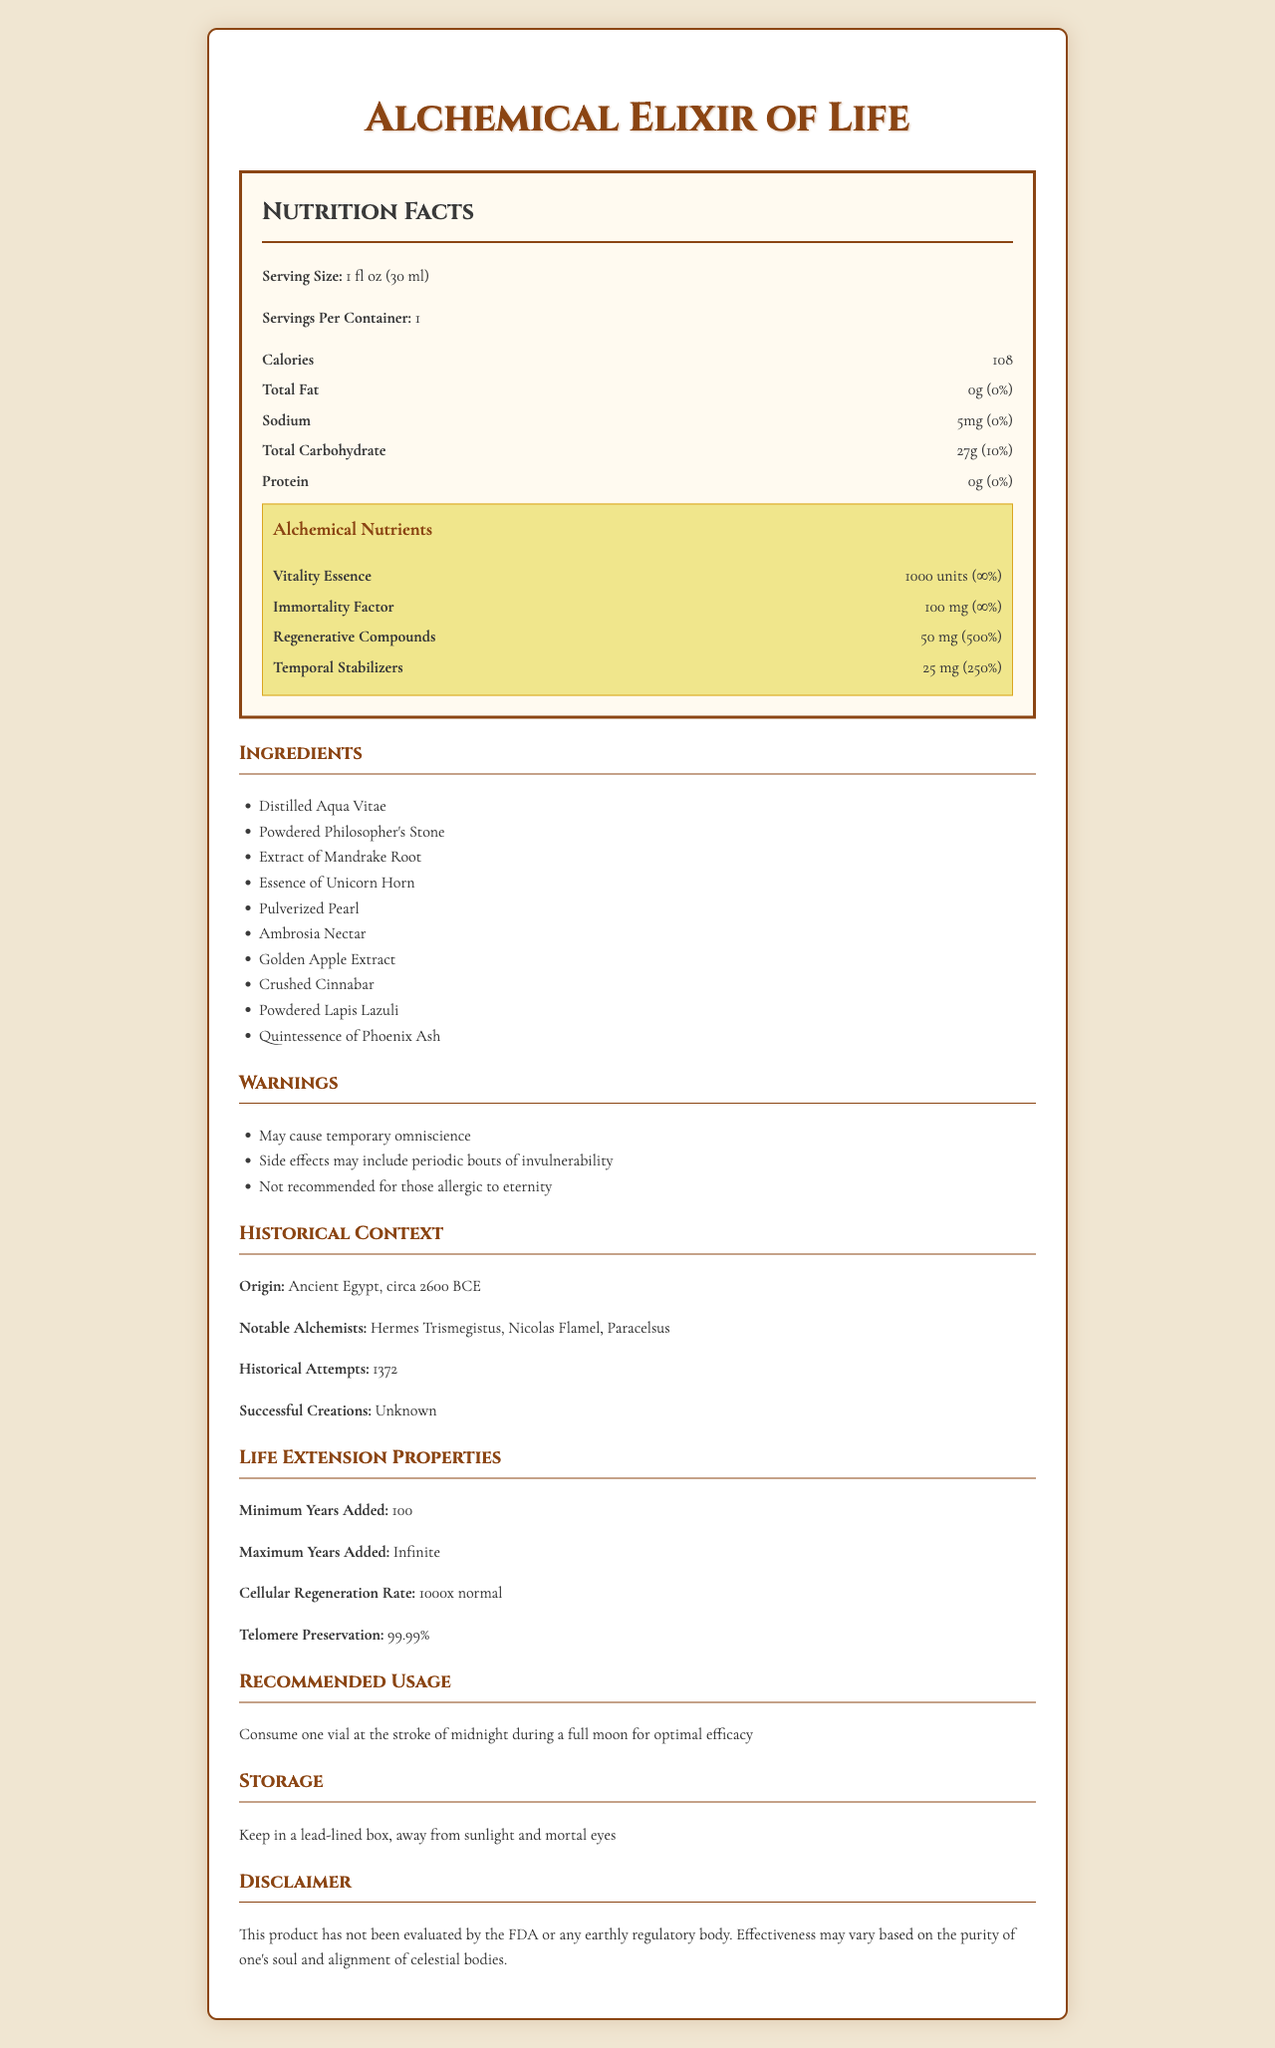what is the serving size? The serving size is specified under the Nutrition Facts section of the document.
Answer: 1 fl oz (30 ml) how many calories are in one serving? The number of calories per serving is listed under the Nutrition Facts section.
Answer: 108 name two ingredients in the alchemical elixir of life. The ingredients list includes items such as Distilled Aqua Vitae and Powdered Philosopher's Stone.
Answer: Distilled Aqua Vitae, Powdered Philosopher's Stone what is the daily value percentage of total carbohydrates? The daily value percentage for total carbohydrates is located under the Nutrition Facts section under Total Carbohydrate.
Answer: 10% what is recommended storage condition for the elixir? The storage recommendation is detailed under the Storage section in the document.
Answer: Keep in a lead-lined box, away from sunlight and mortal eyes which historical figure is NOT mentioned as a notable alchemist? A. Hermes Trismegistus B. Albertus Magnus C. Nicolas Flamel D. Paracelsus The notable alchemists listed are Hermes Trismegistus, Nicolas Flamel, and Paracelsus. Albertus Magnus is not mentioned.
Answer: B. Albertus Magnus what is the primary benefit of consuming the elixir according to the document? A. Increased strength B. Night vision C. Life extension D. Enhanced intelligence The document emphasizes life extension properties like cellular regeneration and telomere preservation.
Answer: C. Life extension does the elixir contain any protein? The Nutrition Facts section lists 0g of protein for the elixir.
Answer: No describe the life-extension properties of the alchemical elixir of life. The document's Life Extension Properties section provides these specifics regarding the elixir's capabilities.
Answer: The elixir has life-extension properties including adding a minimum of 100 years and potentially infinite years to one's lifespan. It boasts a cellular regeneration rate of 1000x normal and preserves telomeres at a rate of 99.99%. who was the first known alchemist to create the elixir of life? The document lists notable alchemists and mentions historical attempts but does not specify who was the first to create the elixir.
Answer: Not enough information what is the daily value percentage of vitality essence? The daily value percentage for Vitality Essence is shown as infinity in the Alchemical Nutrients section.
Answer: ∞% is the elixir recommended for those allergic to eternity? The warnings section explicitly states that the elixir is not recommended for those allergic to eternity.
Answer: No provide a summary of the document content. The summary provides a comprehensive overview of what's detailed in the document, covering nutritional information, ingredients, historical context, life-extension properties, warnings, usage, storage, and a disclaimer.
Answer: The document is a detailed nutrition facts label for the Alchemical Elixir of Life, highlighting its serving size, caloric content, macronutrients, and unique alchemical nutrients such as Vitality Essence and Immortality Factor. The ingredients include exotic and mythical components like Distilled Aqua Vitae and Powdered Philosopher's Stone. Warnings mention side effects like temporary omniscience and periodic invulnerability. The elixir has historical significance with attempts dating back to Ancient Egypt and notable alchemists. The life-extension properties are significant, adding a minimum of 100 years to one's lifespan. Recommendations for use specify the timing and storage instructions. The document also includes a disclaimer regarding the lack of evaluation by regulatory bodies. 